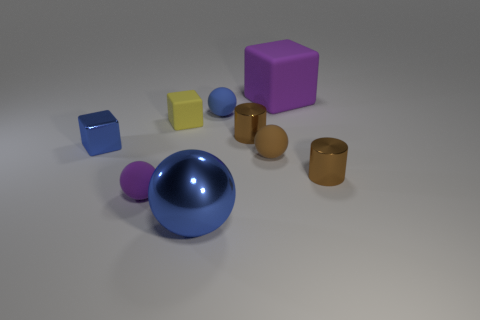How many purple spheres are made of the same material as the big blue thing?
Ensure brevity in your answer.  0. What number of things are either small red metal cylinders or brown metallic cylinders?
Provide a succinct answer. 2. There is a matte cube in front of the large purple object; are there any rubber cubes that are on the left side of it?
Give a very brief answer. No. Are there more big blue objects behind the brown ball than large blue shiny things in front of the large blue metal ball?
Ensure brevity in your answer.  No. There is a big object that is the same color as the metal cube; what is it made of?
Your answer should be compact. Metal. What number of big blocks are the same color as the large metal object?
Ensure brevity in your answer.  0. There is a cube behind the tiny yellow cube; is its color the same as the small sphere to the left of the yellow cube?
Your response must be concise. Yes. Are there any tiny shiny cubes in front of the purple ball?
Your response must be concise. No. What is the small blue block made of?
Provide a succinct answer. Metal. There is a large object on the left side of the large matte cube; what shape is it?
Provide a succinct answer. Sphere. 